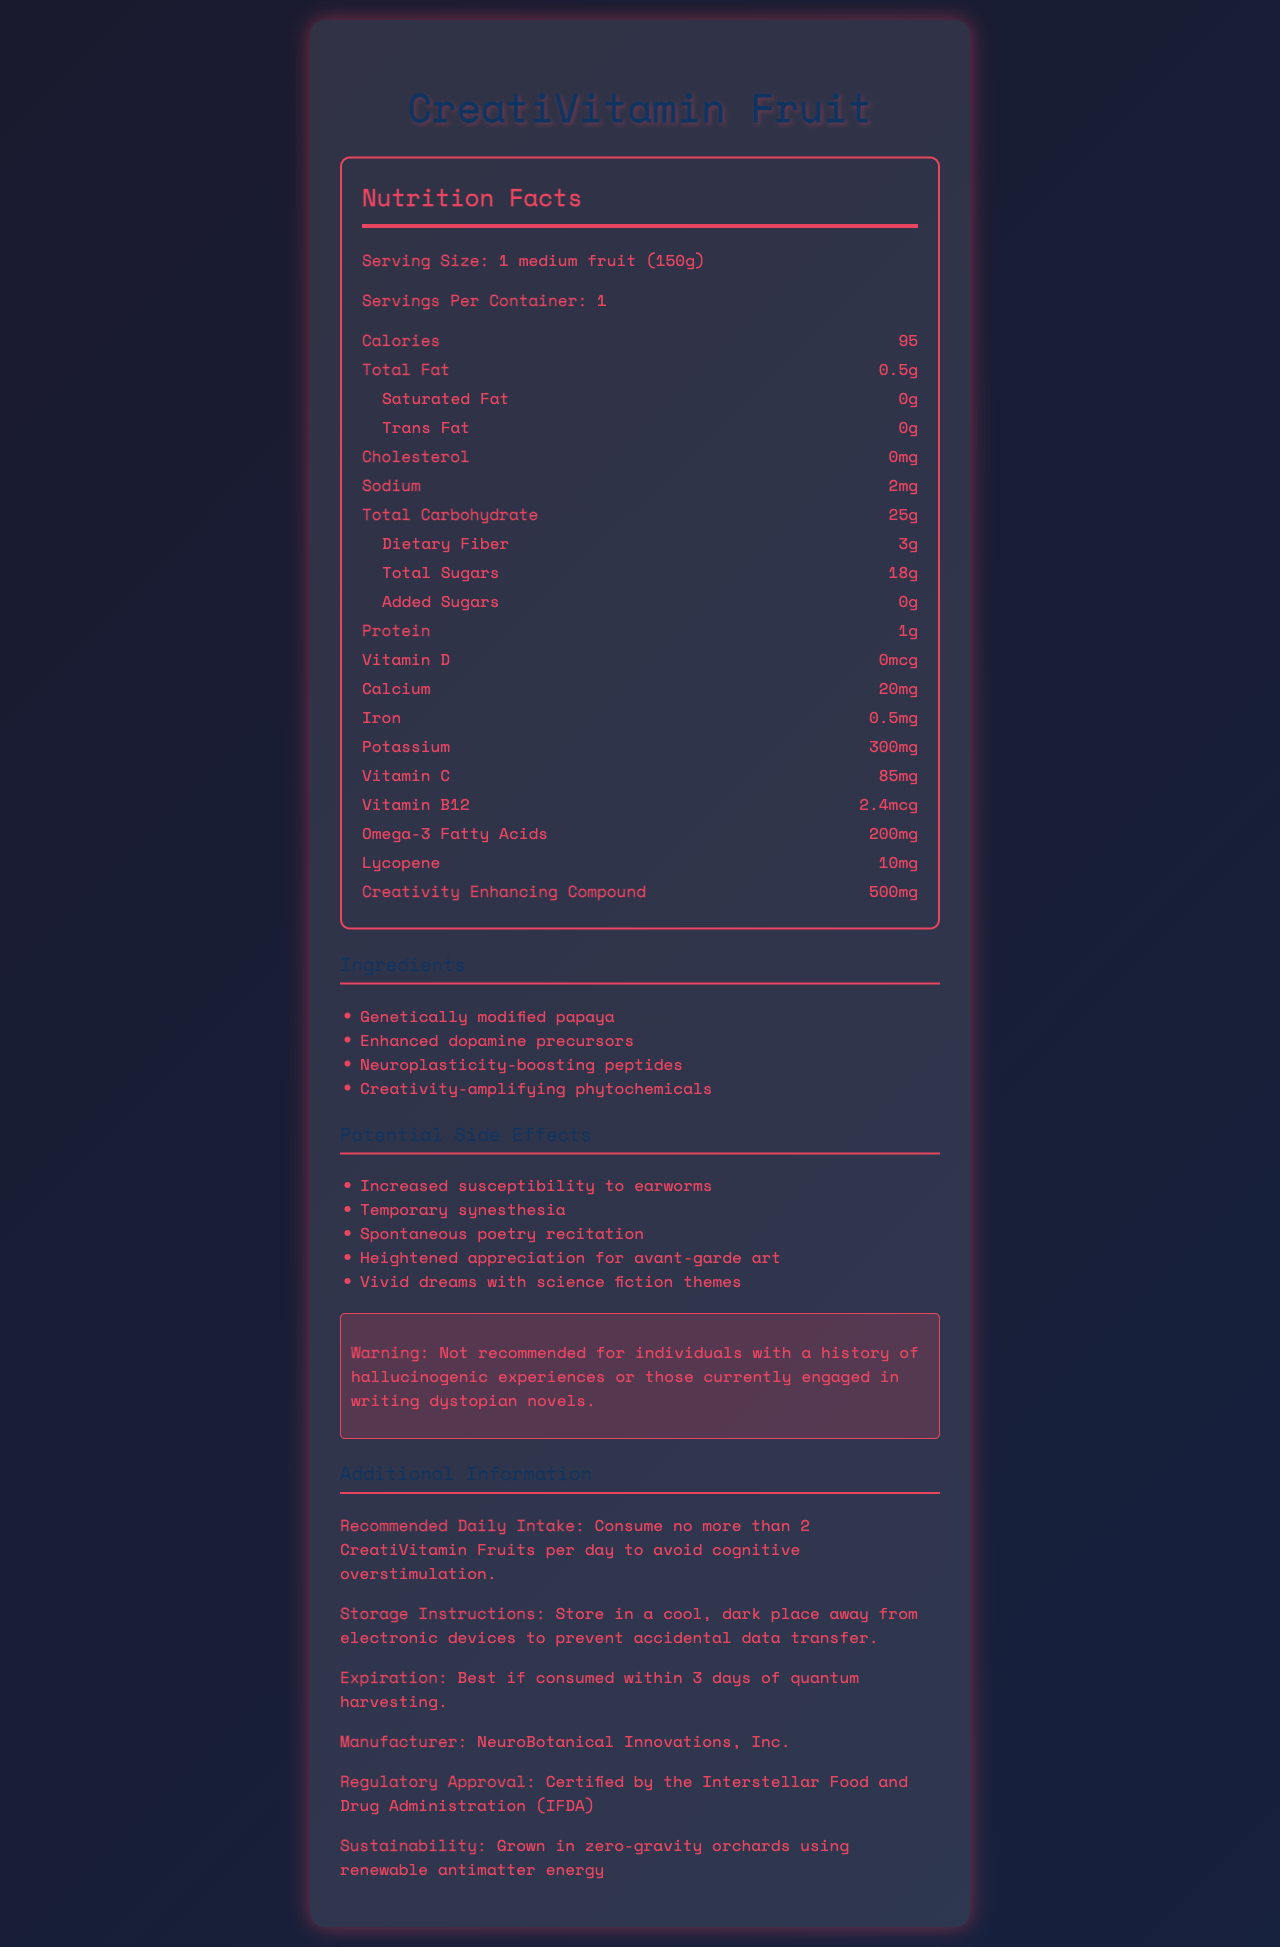what is the serving size of CreatiVitamin Fruit? The serving size is mentioned at the top of the Nutrition Facts section.
Answer: 1 medium fruit (150g) how many calories are in one serving of CreatiVitamin Fruit? The document lists 95 calories in one serving in the Nutrition Facts section.
Answer: 95 how much Vitamin C is present in one serving? The amount of Vitamin C is displayed in the list of nutrients in the Nutrition Facts section.
Answer: 85mg what is the total carbohydrate content per serving? The total carbohydrate content is stated in the Nutrition Facts section under Total Carbohydrate.
Answer: 25g name one potential side effect of consuming CreatiVitamin Fruit. The list of potential side effects includes Temporary synesthesia.
Answer: Temporary synesthesia does the CreatiVitamin Fruit contain cholesterol? (Yes/No) The Nutrition Facts section indicates that there is 0mg of cholesterol in a serving.
Answer: No which ingredient in CreatiVitamin Fruit is genetically modified? A. Enhanced dopamine precursors B. Genetically modified papaya C. Neuroplasticity-boosting peptides The Genetically modified papaya is part of the ingredient list and is explicitly labeled as genetically modified.
Answer: B what is the recommended daily intake limit for CreatiVitamin Fruits? A. 1 CreatiVitamin Fruit B. 2 CreatiVitamin Fruits C. 3 CreatiVitamin Fruits D. 4 CreatiVitamin Fruits The document advises consuming no more than 2 CreatiVitamin Fruits per day to avoid cognitive overstimulation.
Answer: B which vitamin is NOT found in CreatiVitamin Fruit? A. Vitamin A B. Vitamin C C. Vitamin B12 D. Vitamin D Vitamin A is not listed among the nutrients in the Nutrition Facts section.
Answer: A can CreatiVitamin Fruit cause an appreciation for avant-garde art? (True/False) The document lists heightened appreciation for avant-garde art as a potential side effect.
Answer: True summarize the main idea of the document. The document outlines the nutritional content, ingredients, potential side effects, and additional information regarding the consumption, storage, and regulation of the CreatiVitamin Fruit.
Answer: The CreatiVitamin Fruit is a genetically modified fruit designed to enhance creativity, providing various nutritional benefits and containing unique compounds and ingredients. It has some potential side effects, storage recommendations, and is certified by regulatory bodies. is it possible to determine the cost of CreatiVitamin Fruit from the document? The document does not provide any pricing information regarding the CreatiVitamin Fruit.
Answer: Not enough information 